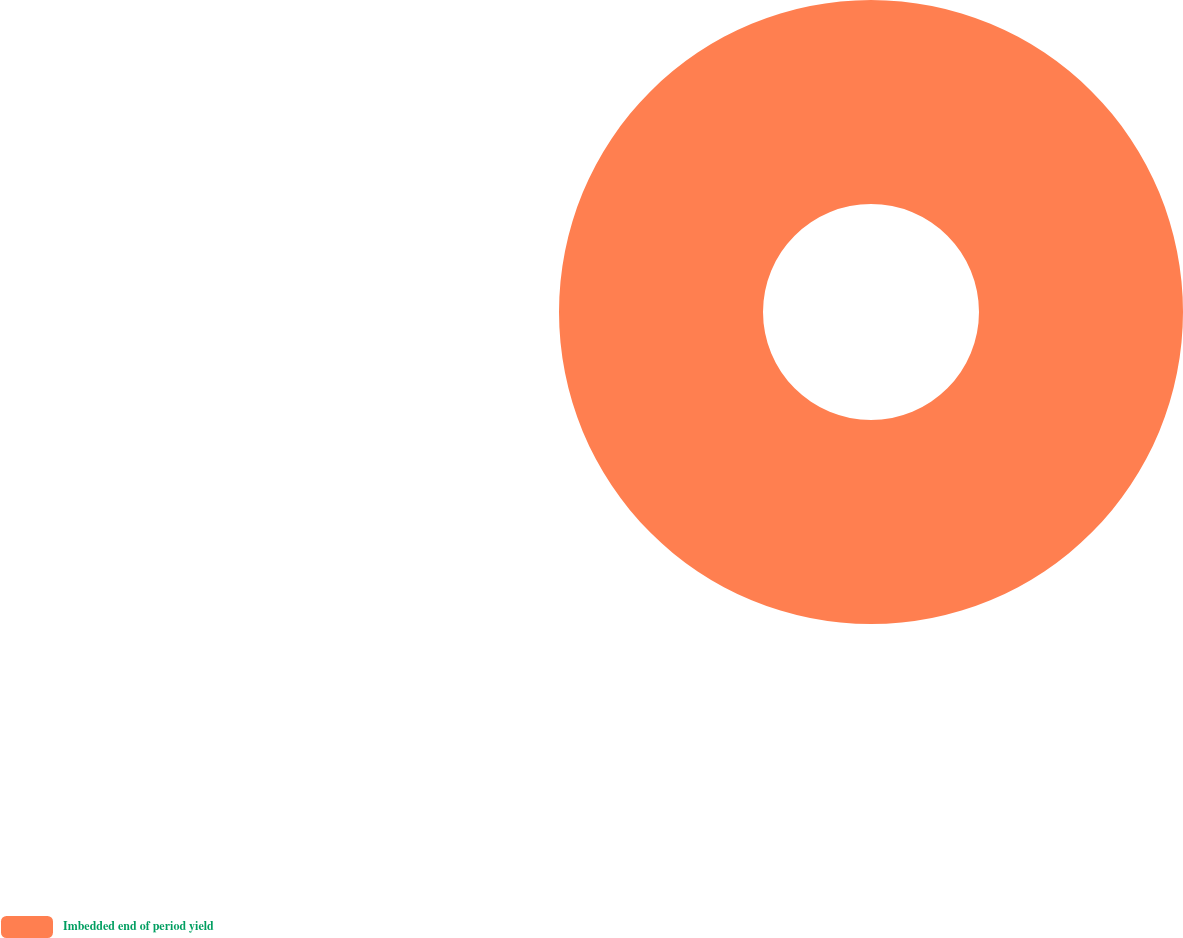Convert chart to OTSL. <chart><loc_0><loc_0><loc_500><loc_500><pie_chart><fcel>Imbedded end of period yield<nl><fcel>100.0%<nl></chart> 